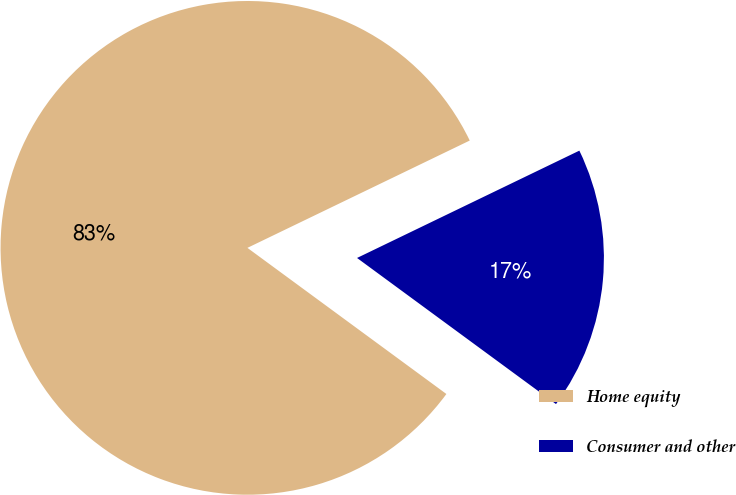<chart> <loc_0><loc_0><loc_500><loc_500><pie_chart><fcel>Home equity<fcel>Consumer and other<nl><fcel>82.76%<fcel>17.24%<nl></chart> 